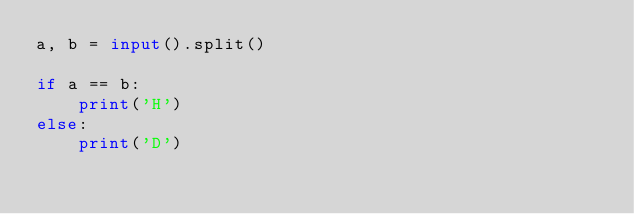Convert code to text. <code><loc_0><loc_0><loc_500><loc_500><_Python_>a, b = input().split()

if a == b:
    print('H')
else:
    print('D')</code> 